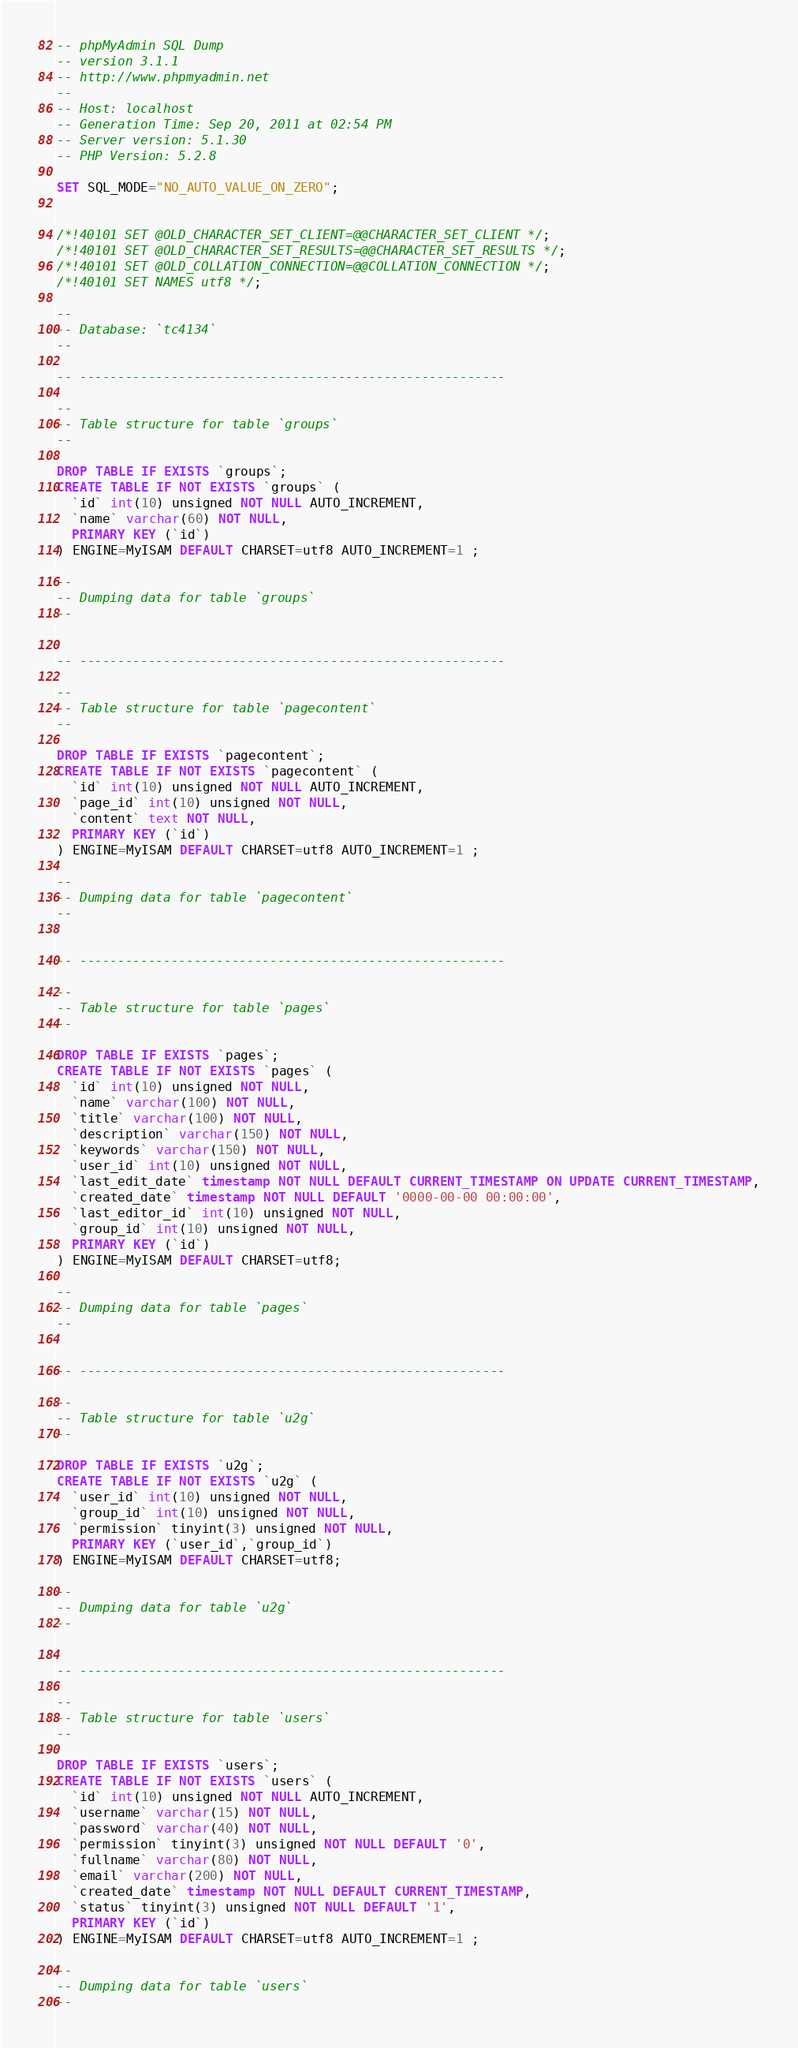<code> <loc_0><loc_0><loc_500><loc_500><_SQL_>-- phpMyAdmin SQL Dump
-- version 3.1.1
-- http://www.phpmyadmin.net
--
-- Host: localhost
-- Generation Time: Sep 20, 2011 at 02:54 PM
-- Server version: 5.1.30
-- PHP Version: 5.2.8

SET SQL_MODE="NO_AUTO_VALUE_ON_ZERO";


/*!40101 SET @OLD_CHARACTER_SET_CLIENT=@@CHARACTER_SET_CLIENT */;
/*!40101 SET @OLD_CHARACTER_SET_RESULTS=@@CHARACTER_SET_RESULTS */;
/*!40101 SET @OLD_COLLATION_CONNECTION=@@COLLATION_CONNECTION */;
/*!40101 SET NAMES utf8 */;

--
-- Database: `tc4134`
--

-- --------------------------------------------------------

--
-- Table structure for table `groups`
--

DROP TABLE IF EXISTS `groups`;
CREATE TABLE IF NOT EXISTS `groups` (
  `id` int(10) unsigned NOT NULL AUTO_INCREMENT,
  `name` varchar(60) NOT NULL,
  PRIMARY KEY (`id`)
) ENGINE=MyISAM DEFAULT CHARSET=utf8 AUTO_INCREMENT=1 ;

--
-- Dumping data for table `groups`
--


-- --------------------------------------------------------

--
-- Table structure for table `pagecontent`
--

DROP TABLE IF EXISTS `pagecontent`;
CREATE TABLE IF NOT EXISTS `pagecontent` (
  `id` int(10) unsigned NOT NULL AUTO_INCREMENT,
  `page_id` int(10) unsigned NOT NULL,
  `content` text NOT NULL,
  PRIMARY KEY (`id`)
) ENGINE=MyISAM DEFAULT CHARSET=utf8 AUTO_INCREMENT=1 ;

--
-- Dumping data for table `pagecontent`
--


-- --------------------------------------------------------

--
-- Table structure for table `pages`
--

DROP TABLE IF EXISTS `pages`;
CREATE TABLE IF NOT EXISTS `pages` (
  `id` int(10) unsigned NOT NULL,
  `name` varchar(100) NOT NULL,
  `title` varchar(100) NOT NULL,
  `description` varchar(150) NOT NULL,
  `keywords` varchar(150) NOT NULL,
  `user_id` int(10) unsigned NOT NULL,
  `last_edit_date` timestamp NOT NULL DEFAULT CURRENT_TIMESTAMP ON UPDATE CURRENT_TIMESTAMP,
  `created_date` timestamp NOT NULL DEFAULT '0000-00-00 00:00:00',
  `last_editor_id` int(10) unsigned NOT NULL,
  `group_id` int(10) unsigned NOT NULL,
  PRIMARY KEY (`id`)
) ENGINE=MyISAM DEFAULT CHARSET=utf8;

--
-- Dumping data for table `pages`
--


-- --------------------------------------------------------

--
-- Table structure for table `u2g`
--

DROP TABLE IF EXISTS `u2g`;
CREATE TABLE IF NOT EXISTS `u2g` (
  `user_id` int(10) unsigned NOT NULL,
  `group_id` int(10) unsigned NOT NULL,
  `permission` tinyint(3) unsigned NOT NULL,
  PRIMARY KEY (`user_id`,`group_id`)
) ENGINE=MyISAM DEFAULT CHARSET=utf8;

--
-- Dumping data for table `u2g`
--


-- --------------------------------------------------------

--
-- Table structure for table `users`
--

DROP TABLE IF EXISTS `users`;
CREATE TABLE IF NOT EXISTS `users` (
  `id` int(10) unsigned NOT NULL AUTO_INCREMENT,
  `username` varchar(15) NOT NULL,
  `password` varchar(40) NOT NULL,
  `permission` tinyint(3) unsigned NOT NULL DEFAULT '0',
  `fullname` varchar(80) NOT NULL,
  `email` varchar(200) NOT NULL,
  `created_date` timestamp NOT NULL DEFAULT CURRENT_TIMESTAMP,
  `status` tinyint(3) unsigned NOT NULL DEFAULT '1',
  PRIMARY KEY (`id`)
) ENGINE=MyISAM DEFAULT CHARSET=utf8 AUTO_INCREMENT=1 ;

--
-- Dumping data for table `users`
--

</code> 